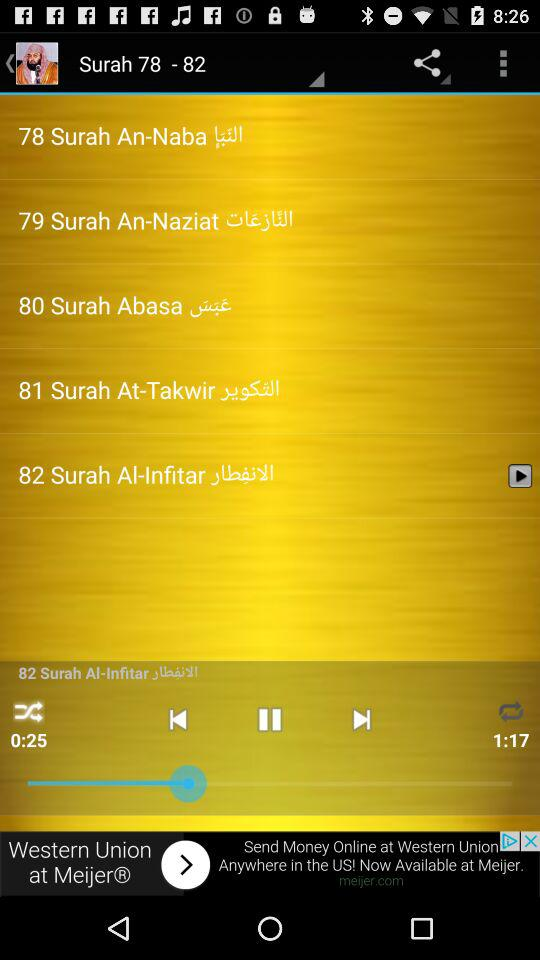What is the duration of the song that is currently playing? The duration of the currently playing song is 1 minute and 17 seconds. 